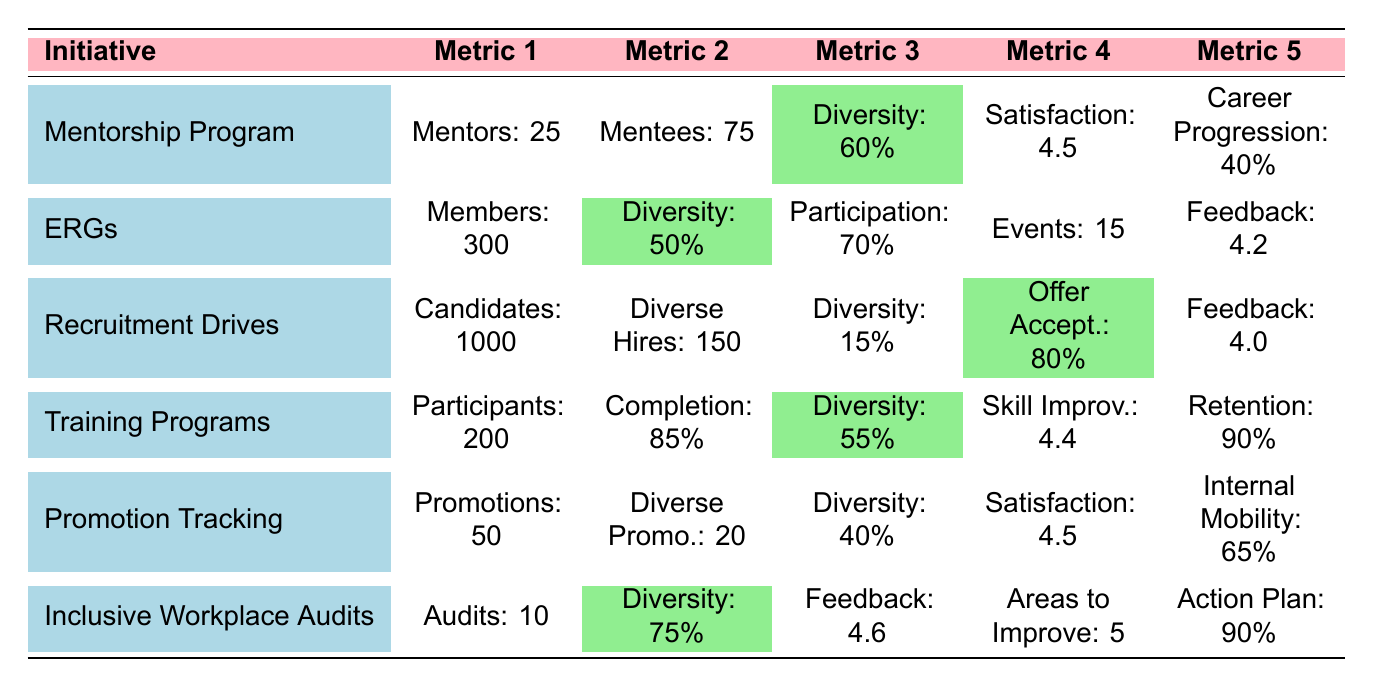What is the diversity percentage for the Mentorship Program? The table shows the Mentorship Program has a diversity percentage highlighted as 60%.
Answer: 60% How many mentors are involved in the Mentorship Program? The Mentorship Program row states there are 25 mentors.
Answer: 25 What is the satisfaction score for the Promotion Tracking initiative? The satisfaction score for the Promotion Tracking initiative is 4.5 as indicated in the table.
Answer: 4.5 Which initiative has the highest diversity percentage? The Inclusive Workplace Audits has a diversity score of 75%, which is the highest compared to other initiatives in the table.
Answer: 75% What is the average career progression rate across the Mentorship Program and Promotion Tracking? The career progression rate for the Mentorship Program is 40% and for Promotion Tracking is 40%. The average is (40 + 40)/2 = 40%.
Answer: 40% Does the Employee Resource Groups (ERGs) initiative have more than 290 members? The ERGs initiative has 300 members, which is more than 290.
Answer: Yes What are the total diverse hires from the Recruitment Drives compared to the diverse promotions from Promotion Tracking? The table indicates that Recruitment Drives had 150 diverse hires and Promotion Tracking had 20 diverse promotions.
Answer: 150 diverse hires are much more than 20 diverse promotions If we sum the total participants in Training Programs and Mentorship Program, what do we get? The Training Programs have 200 participants, and the Mentorship Program has 75 mentees (considering them as participants). Adding them gives 200 + 75 = 275.
Answer: 275 What was the total number of audits conducted in the Inclusive Workplace Audits initiative? The Inclusive Workplace Audits initiative indicates that a total of 10 audits were conducted according to the table.
Answer: 10 Which initiative has the highest Skill Improvement Score, and what is that score? The Training Programs have a Skill Improvement Score of 4.4, which is the highest among all initiatives presented in the table.
Answer: 4.4 